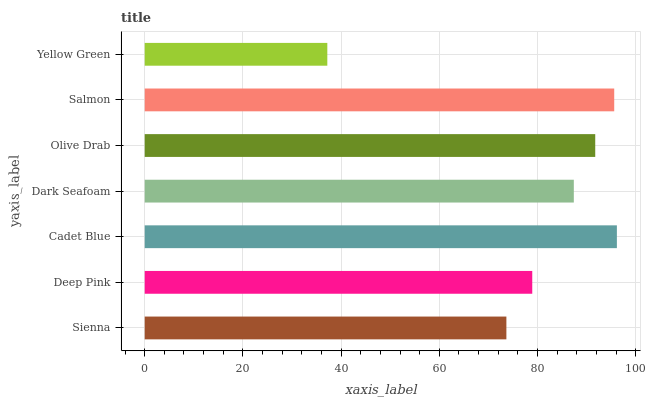Is Yellow Green the minimum?
Answer yes or no. Yes. Is Cadet Blue the maximum?
Answer yes or no. Yes. Is Deep Pink the minimum?
Answer yes or no. No. Is Deep Pink the maximum?
Answer yes or no. No. Is Deep Pink greater than Sienna?
Answer yes or no. Yes. Is Sienna less than Deep Pink?
Answer yes or no. Yes. Is Sienna greater than Deep Pink?
Answer yes or no. No. Is Deep Pink less than Sienna?
Answer yes or no. No. Is Dark Seafoam the high median?
Answer yes or no. Yes. Is Dark Seafoam the low median?
Answer yes or no. Yes. Is Cadet Blue the high median?
Answer yes or no. No. Is Sienna the low median?
Answer yes or no. No. 